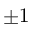<formula> <loc_0><loc_0><loc_500><loc_500>\pm 1</formula> 